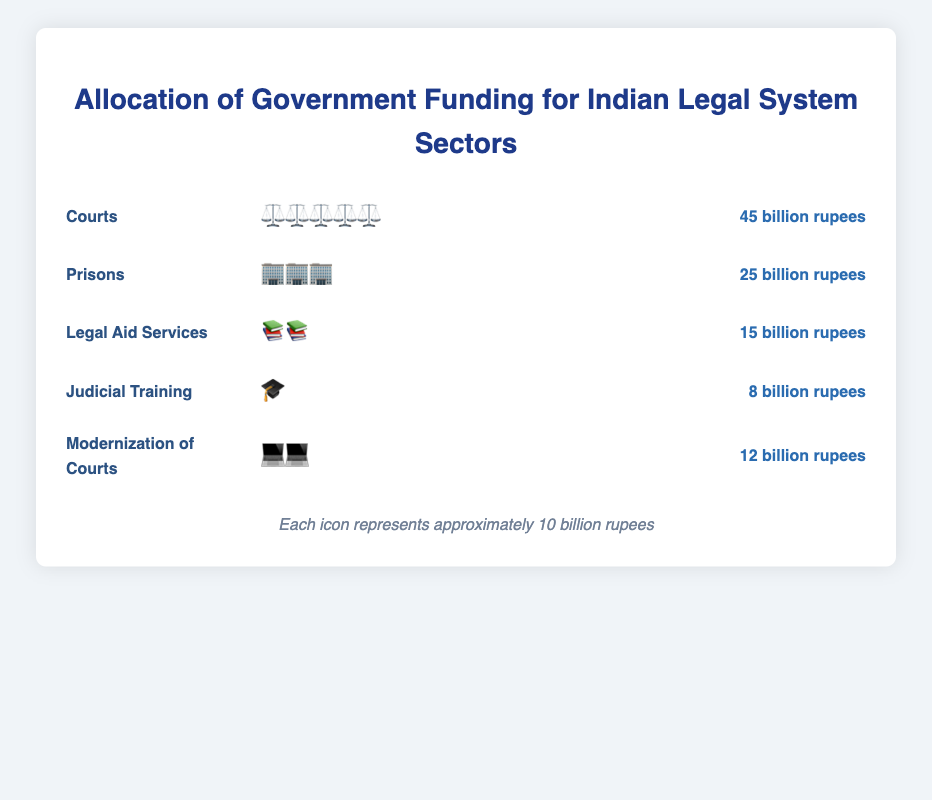What is the total funding allocated to Courts? The figure shows that Courts have been allocated 45 billion rupees.
Answer: 45 billion rupees How many icons represent the funding for Legal Aid Services? Each icon represents approximately 10 billion rupees. Legal Aid Services have a total funding of 15 billion rupees, so the number of icons is 15/10 = 1.5, which is approximately 2 icons.
Answer: 2 Which sector received the least amount of funding? By looking at the figure, Judicial Training has the lowest funding at 8 billion rupees.
Answer: Judicial Training How much more funding is allocated to Prisons than Judicial Training? The funding for Prisons is 25 billion rupees while Judicial Training receives 8 billion rupees. The difference is 25 - 8 = 17 billion rupees.
Answer: 17 billion rupees Which sector received more funding: Modernization of Courts or Legal Aid Services? The figure shows that Modernization of Courts has 12 billion rupees and Legal Aid Services have 15 billion rupees. Therefore, Legal Aid Services received more funding.
Answer: Legal Aid Services How many icons are there for the sector with the highest funding? The Courts sector received the highest funding of 45 billion rupees. Each icon represents approximately 10 billion rupees, so there should be 45/10 = 4.5, which is approximately 5 icons.
Answer: 5 What is the total funding allocated across all sectors? Add the funding of all sectors: 45 (Courts) + 25 (Prisons) + 15 (Legal Aid Services) + 8 (Judicial Training) + 12 (Modernization of Courts). The total is 105 billion rupees.
Answer: 105 billion rupees Which sector has more icons: Prisons or Modernization of Courts? Prisons have 25 billion rupees resulting in approximately 3 icons and Modernization of Courts have 12 billion rupees resulting in approximately 2 icons. Therefore, Prisons have more icons.
Answer: Prisons 